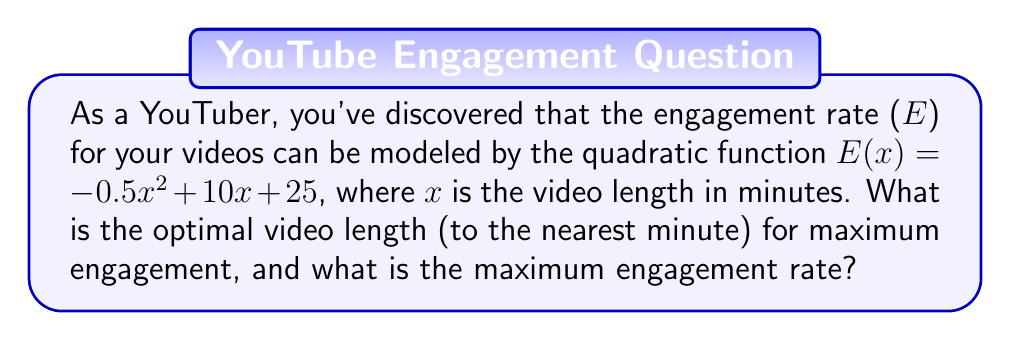Solve this math problem. 1) The quadratic function given is $E(x) = -0.5x^2 + 10x + 25$, where E is the engagement rate and x is the video length in minutes.

2) To find the maximum point of a quadratic function, we need to find the vertex. For a quadratic function in the form $f(x) = ax^2 + bx + c$, the x-coordinate of the vertex is given by $x = -\frac{b}{2a}$.

3) In this case, $a = -0.5$ and $b = 10$. So:

   $x = -\frac{10}{2(-0.5)} = -\frac{10}{-1} = 10$

4) Therefore, the optimal video length is 10 minutes.

5) To find the maximum engagement rate, we substitute x = 10 into the original function:

   $E(10) = -0.5(10)^2 + 10(10) + 25$
   $= -0.5(100) + 100 + 25$
   $= -50 + 100 + 25$
   $= 75$

6) Therefore, the maximum engagement rate is 75.
Answer: 10 minutes; 75 